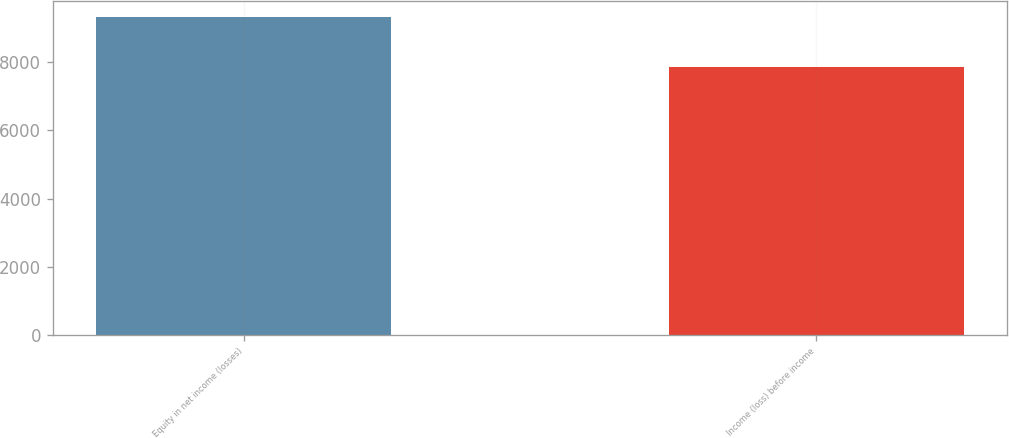<chart> <loc_0><loc_0><loc_500><loc_500><bar_chart><fcel>Equity in net income (losses)<fcel>Income (loss) before income<nl><fcel>9330<fcel>7868<nl></chart> 